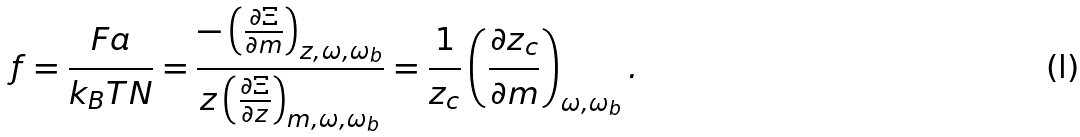Convert formula to latex. <formula><loc_0><loc_0><loc_500><loc_500>f = \frac { F a } { k _ { B } T N } = \frac { - \left ( \frac { \partial \Xi } { \partial m } \right ) _ { z , \omega , \omega _ { b } } } { z \left ( \frac { \partial \Xi } { \partial z } \right ) _ { m , \omega , \omega _ { b } } } = \frac { 1 } { z _ { c } } \left ( \frac { \partial z _ { c } } { \partial m } \right ) _ { \omega , \omega _ { b } } .</formula> 